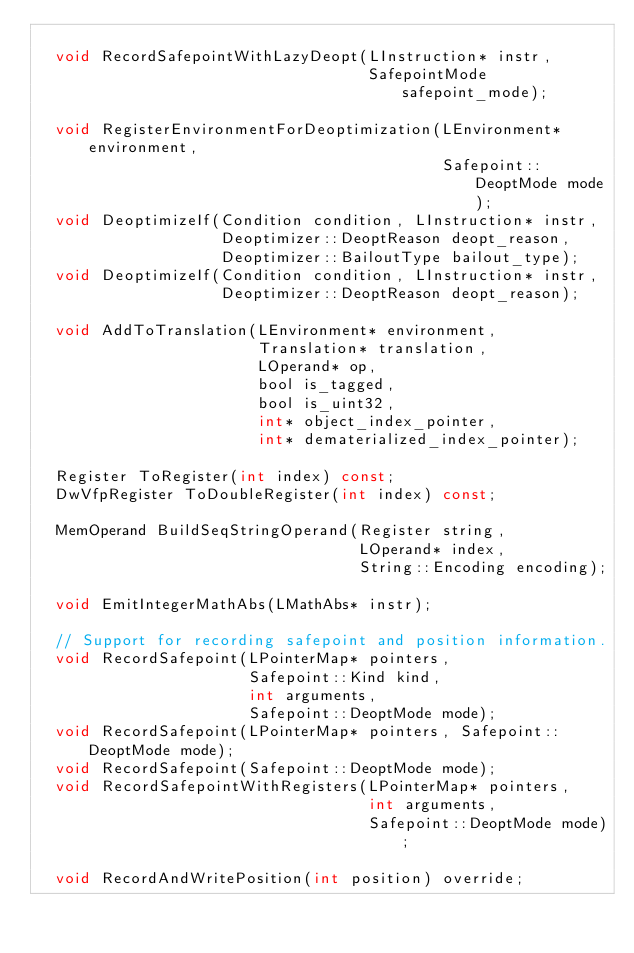Convert code to text. <code><loc_0><loc_0><loc_500><loc_500><_C_>
  void RecordSafepointWithLazyDeopt(LInstruction* instr,
                                    SafepointMode safepoint_mode);

  void RegisterEnvironmentForDeoptimization(LEnvironment* environment,
                                            Safepoint::DeoptMode mode);
  void DeoptimizeIf(Condition condition, LInstruction* instr,
                    Deoptimizer::DeoptReason deopt_reason,
                    Deoptimizer::BailoutType bailout_type);
  void DeoptimizeIf(Condition condition, LInstruction* instr,
                    Deoptimizer::DeoptReason deopt_reason);

  void AddToTranslation(LEnvironment* environment,
                        Translation* translation,
                        LOperand* op,
                        bool is_tagged,
                        bool is_uint32,
                        int* object_index_pointer,
                        int* dematerialized_index_pointer);

  Register ToRegister(int index) const;
  DwVfpRegister ToDoubleRegister(int index) const;

  MemOperand BuildSeqStringOperand(Register string,
                                   LOperand* index,
                                   String::Encoding encoding);

  void EmitIntegerMathAbs(LMathAbs* instr);

  // Support for recording safepoint and position information.
  void RecordSafepoint(LPointerMap* pointers,
                       Safepoint::Kind kind,
                       int arguments,
                       Safepoint::DeoptMode mode);
  void RecordSafepoint(LPointerMap* pointers, Safepoint::DeoptMode mode);
  void RecordSafepoint(Safepoint::DeoptMode mode);
  void RecordSafepointWithRegisters(LPointerMap* pointers,
                                    int arguments,
                                    Safepoint::DeoptMode mode);

  void RecordAndWritePosition(int position) override;
</code> 